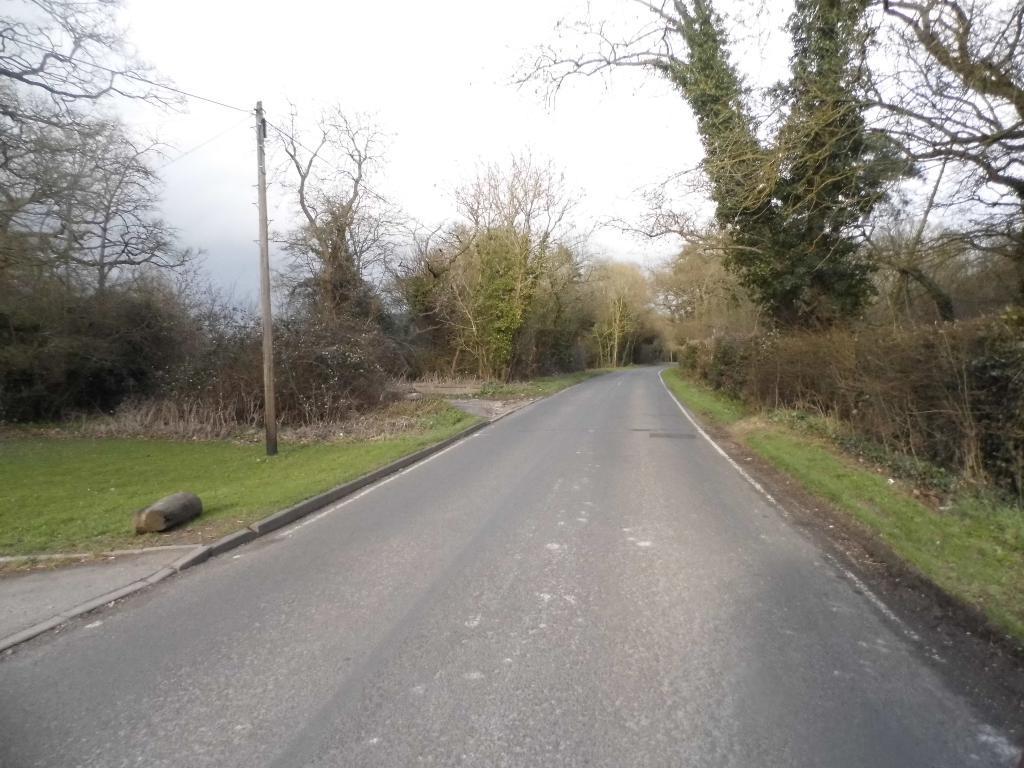Please provide a concise description of this image. In this image I can see trees in green color. I can also see few electric poles and sky is in white color. 